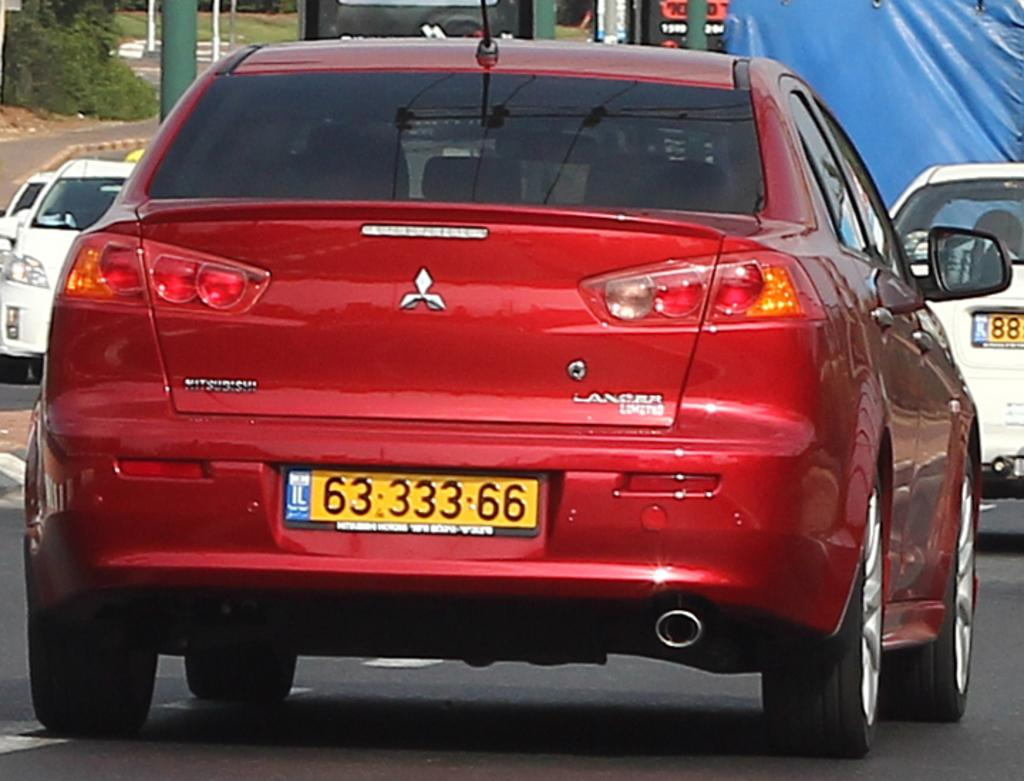Provide a one-sentence caption for the provided image. A red Mitsubishi car with a license plate of 6333366. 